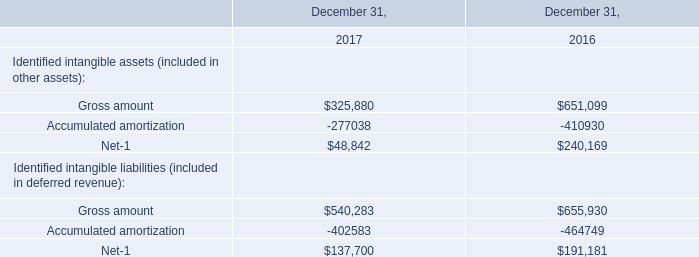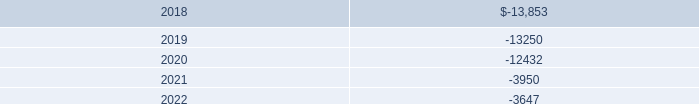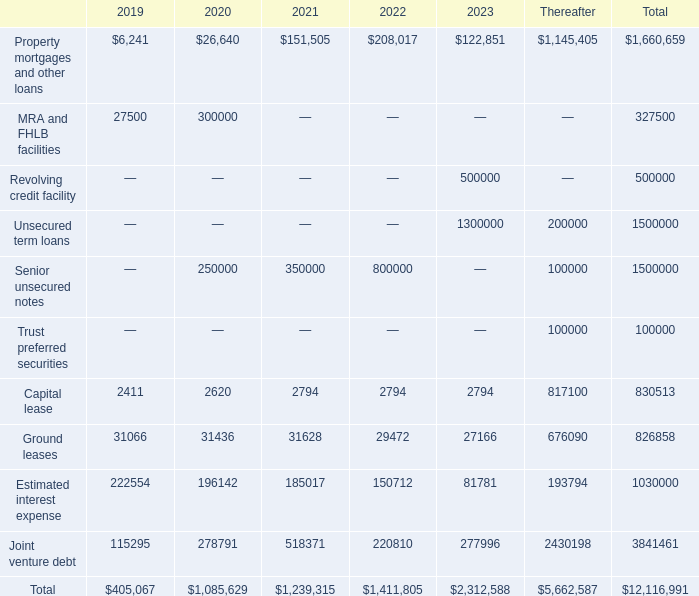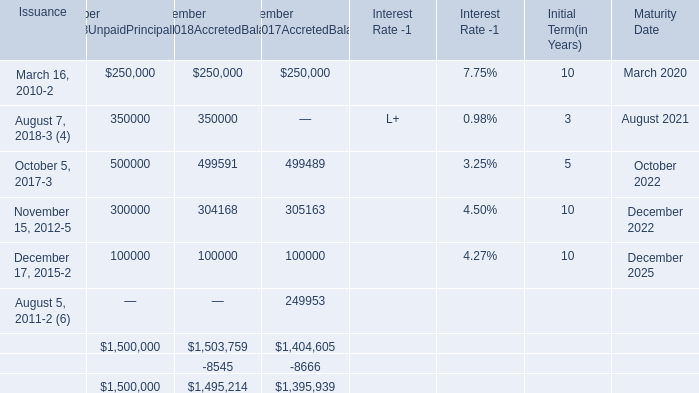What is the total amount of Property mortgages and other loans of 2020, and December 17, 2015 of Maturity Date is ? 
Computations: (26640.0 + 2025.0)
Answer: 28665.0. 